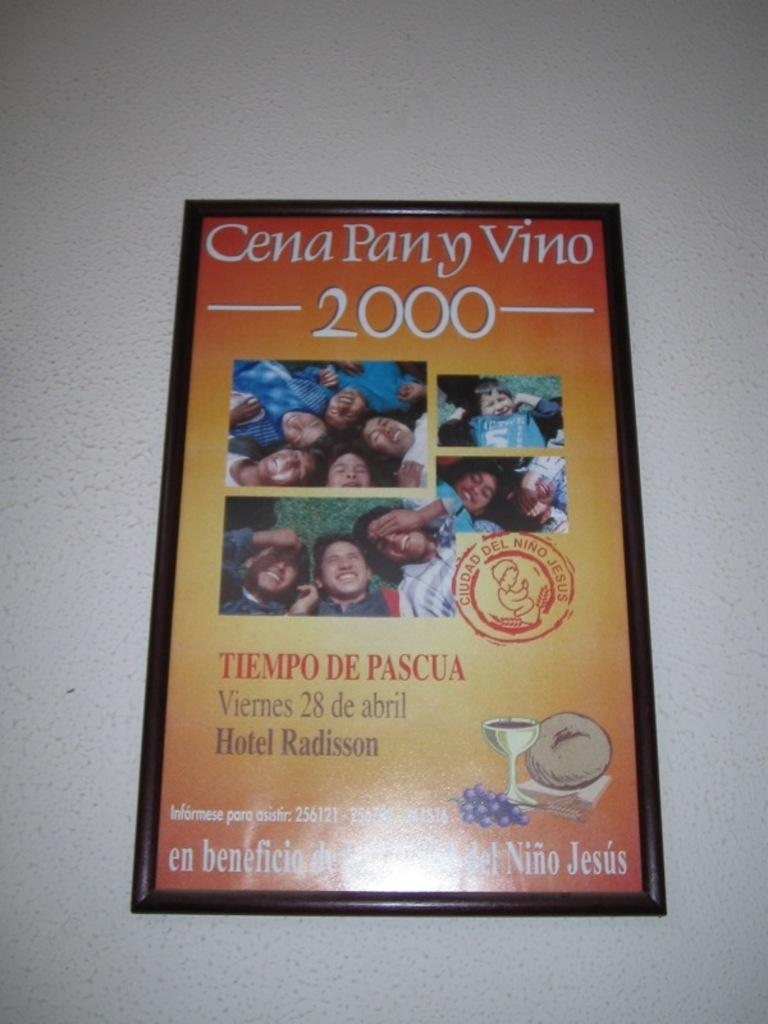<image>
Render a clear and concise summary of the photo. A colorful framed poster hangs on a white wall and advertised a 2000 event at the Hotel Radisson. 